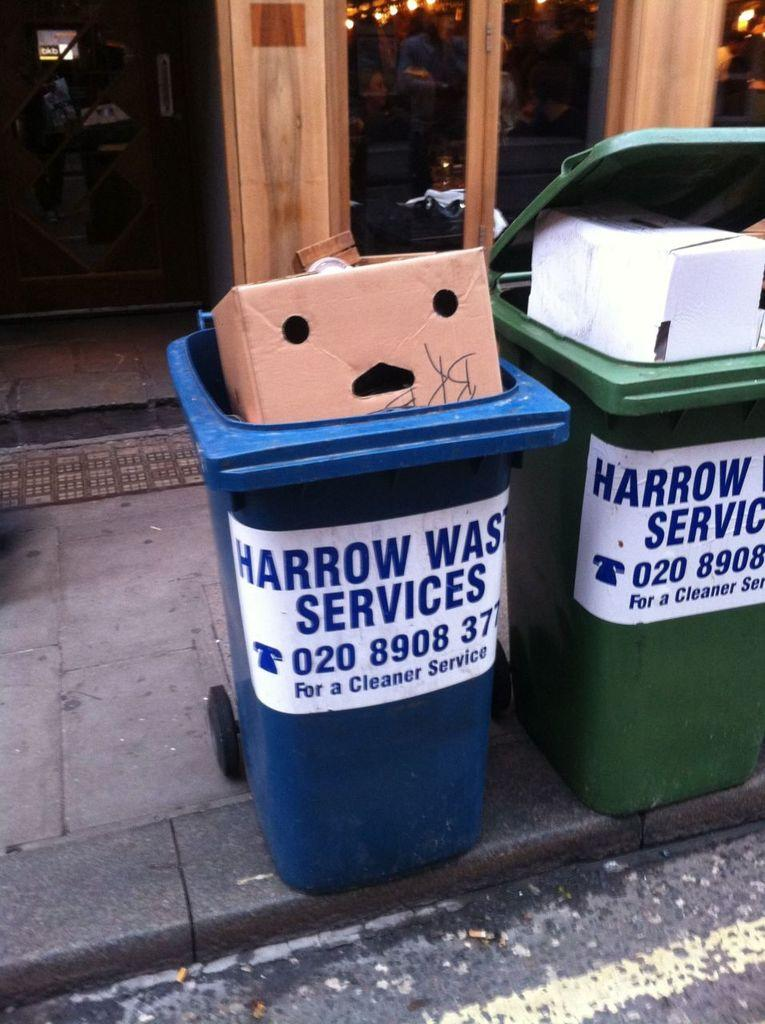<image>
Write a terse but informative summary of the picture. Trash and recyle bins from Harrow Waste Services on a curb are very full. 